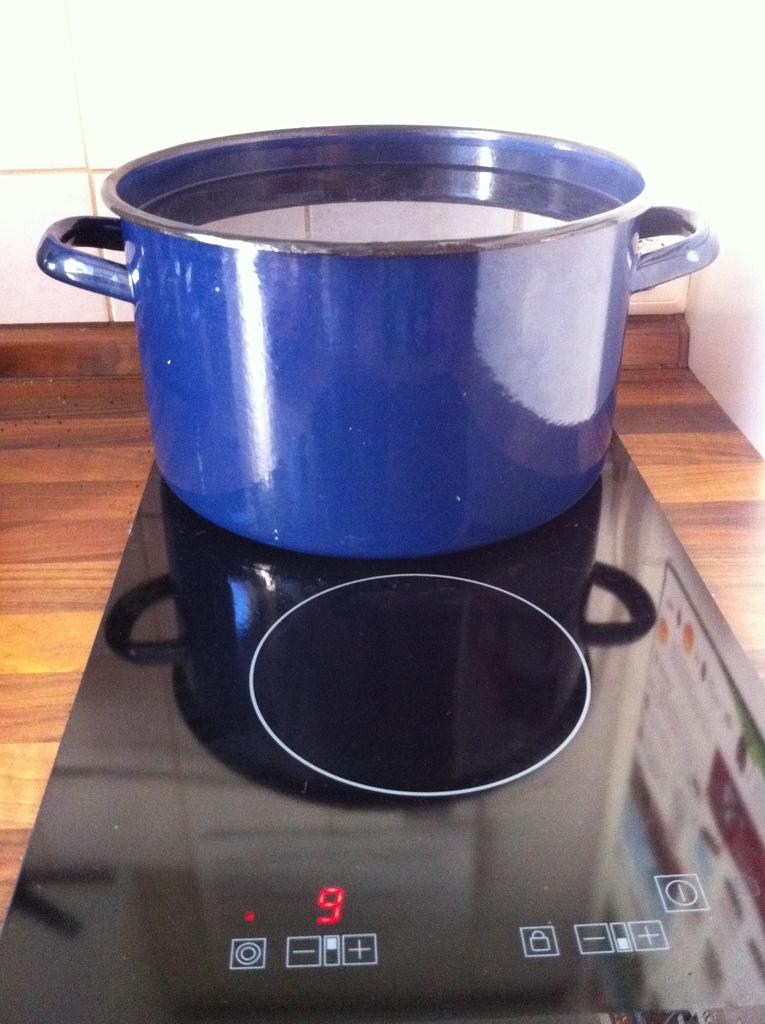<image>
Share a concise interpretation of the image provided. A blue pot full of water sitting on a stove burner that is set to 9. 